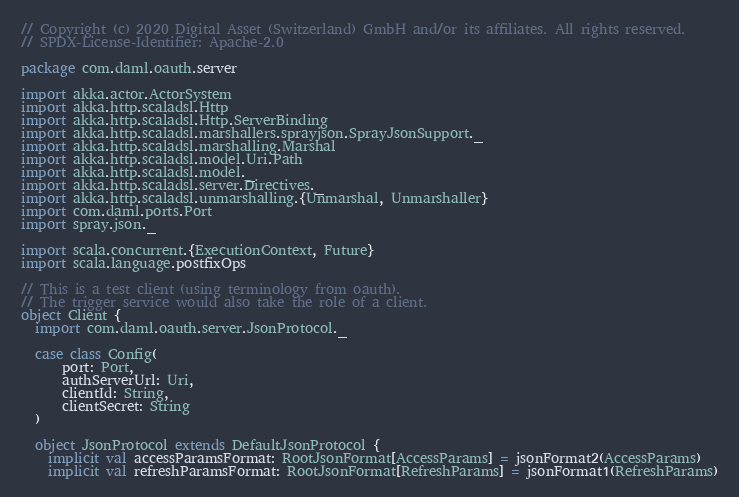Convert code to text. <code><loc_0><loc_0><loc_500><loc_500><_Scala_>// Copyright (c) 2020 Digital Asset (Switzerland) GmbH and/or its affiliates. All rights reserved.
// SPDX-License-Identifier: Apache-2.0

package com.daml.oauth.server

import akka.actor.ActorSystem
import akka.http.scaladsl.Http
import akka.http.scaladsl.Http.ServerBinding
import akka.http.scaladsl.marshallers.sprayjson.SprayJsonSupport._
import akka.http.scaladsl.marshalling.Marshal
import akka.http.scaladsl.model.Uri.Path
import akka.http.scaladsl.model._
import akka.http.scaladsl.server.Directives._
import akka.http.scaladsl.unmarshalling.{Unmarshal, Unmarshaller}
import com.daml.ports.Port
import spray.json._

import scala.concurrent.{ExecutionContext, Future}
import scala.language.postfixOps

// This is a test client (using terminology from oauth).
// The trigger service would also take the role of a client.
object Client {
  import com.daml.oauth.server.JsonProtocol._

  case class Config(
      port: Port,
      authServerUrl: Uri,
      clientId: String,
      clientSecret: String
  )

  object JsonProtocol extends DefaultJsonProtocol {
    implicit val accessParamsFormat: RootJsonFormat[AccessParams] = jsonFormat2(AccessParams)
    implicit val refreshParamsFormat: RootJsonFormat[RefreshParams] = jsonFormat1(RefreshParams)</code> 